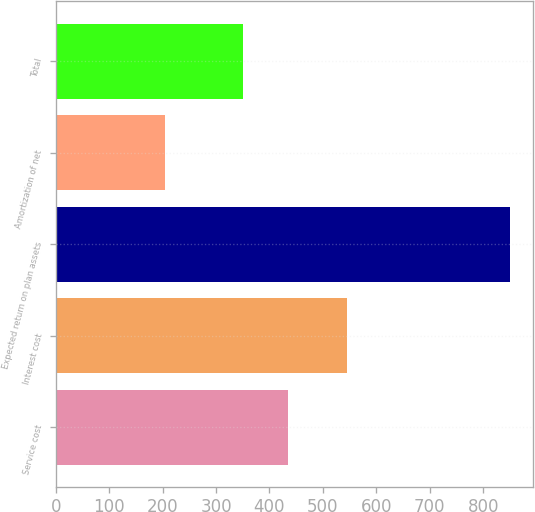Convert chart to OTSL. <chart><loc_0><loc_0><loc_500><loc_500><bar_chart><fcel>Service cost<fcel>Interest cost<fcel>Expected return on plan assets<fcel>Amortization of net<fcel>Total<nl><fcel>435<fcel>546<fcel>850<fcel>205<fcel>351<nl></chart> 